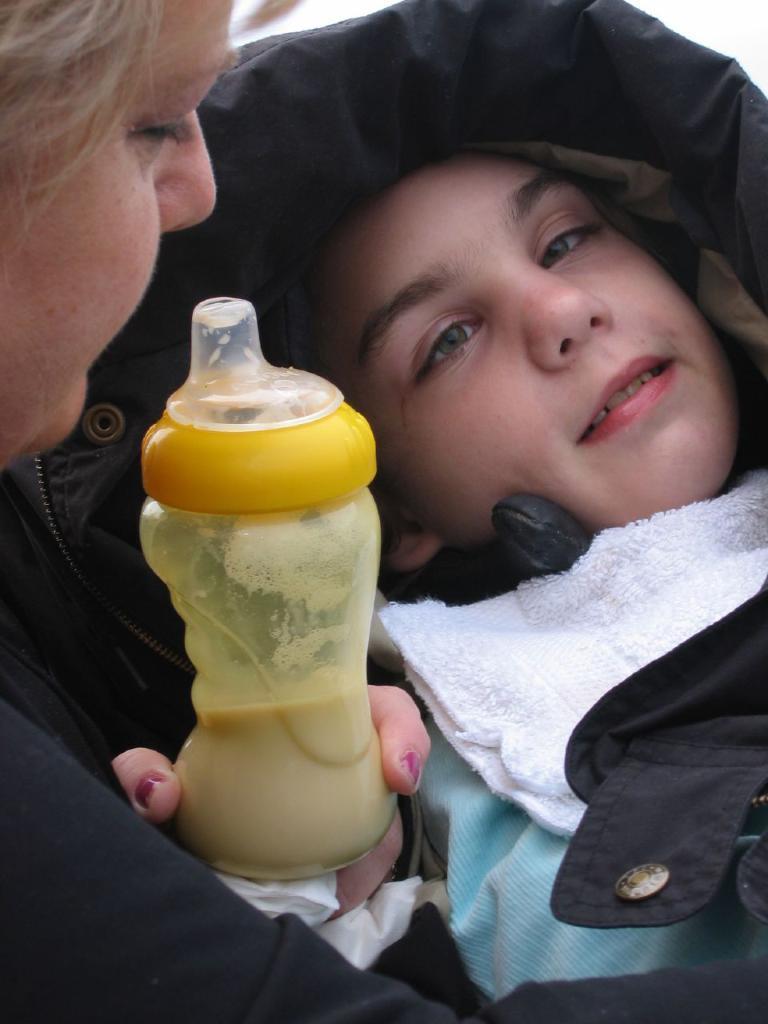Could you give a brief overview of what you see in this image? In this image we can see a boy is sleeping, and in front here is the woman sitting, and holding the milk bottle in the hand. 